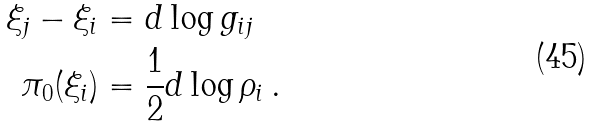<formula> <loc_0><loc_0><loc_500><loc_500>\xi _ { j } - \xi _ { i } & = d \log g _ { i j } \\ \pi _ { 0 } ( \xi _ { i } ) & = \frac { 1 } { 2 } d \log \rho _ { i } \, .</formula> 